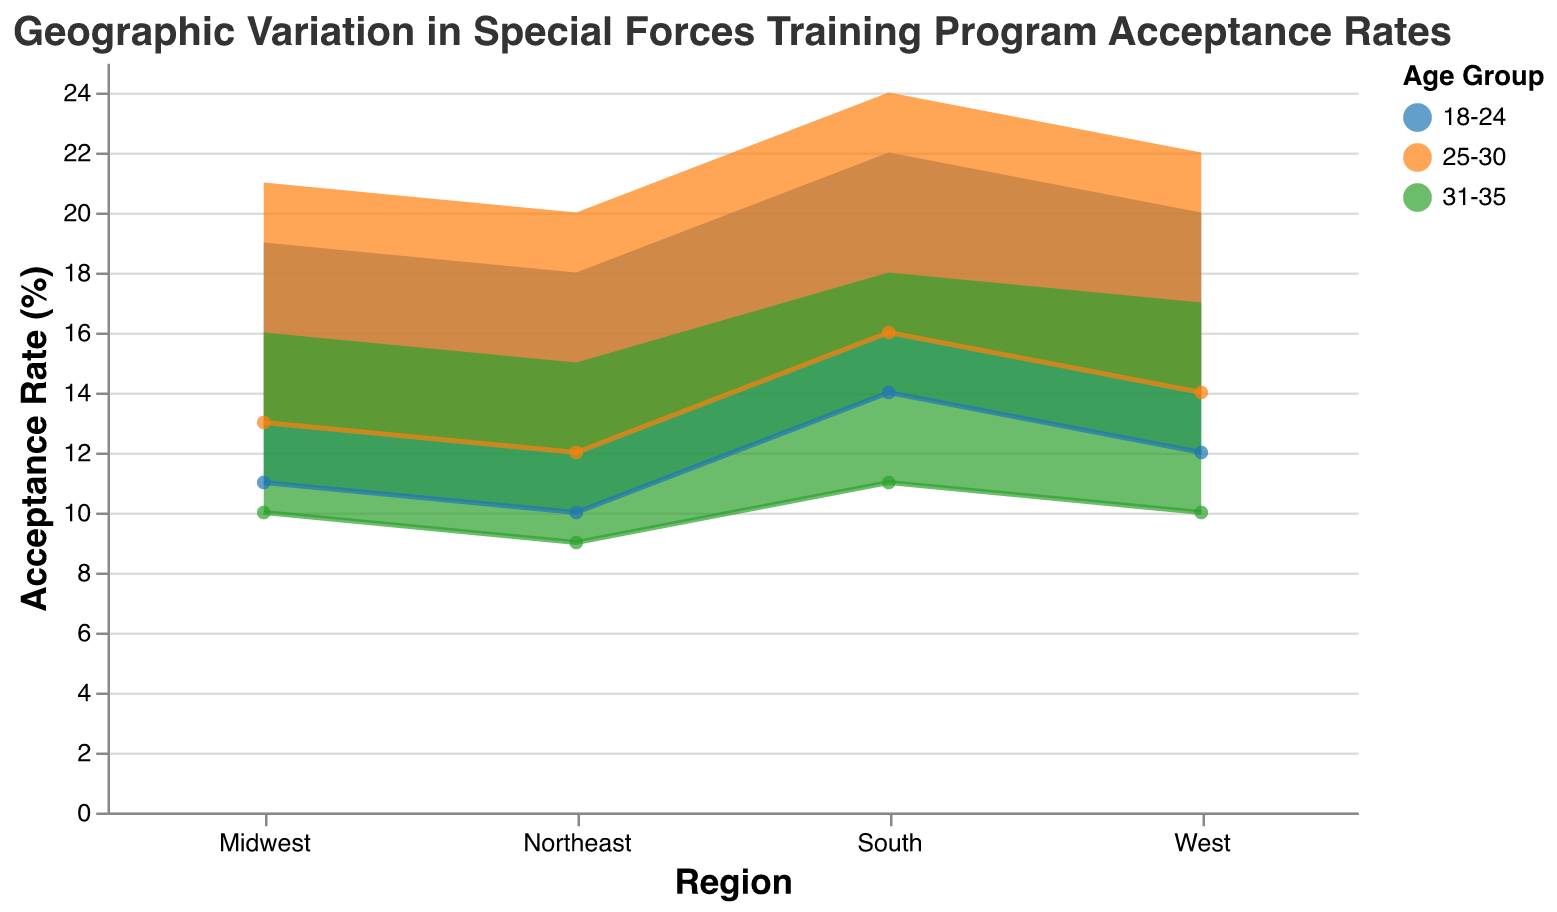What is the title of the chart? The title is located at the top of the chart in a larger font size and provides a brief description of the data being visualized.
Answer: Geographic Variation in Special Forces Training Program Acceptance Rates Which region has the highest acceptance rate range for the 25-30 age group? Identify the color corresponding to the 25-30 age group in the legend, then check the vertical bars representing each region, focusing on the height. The South region shows the highest range (16-24%).
Answer: South What is the difference in the maximum acceptance rate between the 18-24 and 31-35 age group in the Northeast region? For the Northeast region, retrieve the maximum acceptance rates for both age groups from the chart (18% for 18-24 and 15% for 31-35), then subtract the two values: 18 - 15.
Answer: 3% Which age group has the smallest acceptance rate range in the West region? Check the acceptance rate ranges (y2 - y1) for each age group within the West region bars. The 31-35 age group ranges from 10 to 17, which is a 7% range.
Answer: 31-35 How does the acceptance rate range for the Midwest region's 18-24 age group compare to the West region's 25-30 age group? Note the acceptance rate ranges for both (Midwest 18-24: 11-19% and West 25-30: 14-22%). Both have an acceptance rate range width of 8%.
Answer: Equal What is the average of the minimum acceptance rates for all age groups in the South region? Add the minimum acceptance rates for all age groups in the South (14%, 16%, and 11%) and divide by the number of age groups: (14 + 16 + 11)/3.
Answer: 13.67% Which age group in the Northeast region shows the largest disparity between their minimum and maximum acceptance rates? Calculate the range for each age group in the Northeast (18-24: 18-10=8%, 25-30: 20-12=8%, 31-35: 15-9=6%). The 18-24 and 25-30 age groups both have the largest disparity of 8%.
Answer: 18-24 and 25-30 Is it true that the acceptance rate range of 18-24 age group in the Northeast is narrower than in the South? Compare the range widths for the 18-24 age group in both regions (Northeast: 8%, South: 8%). They have identical range widths, so the statement is false.
Answer: False 